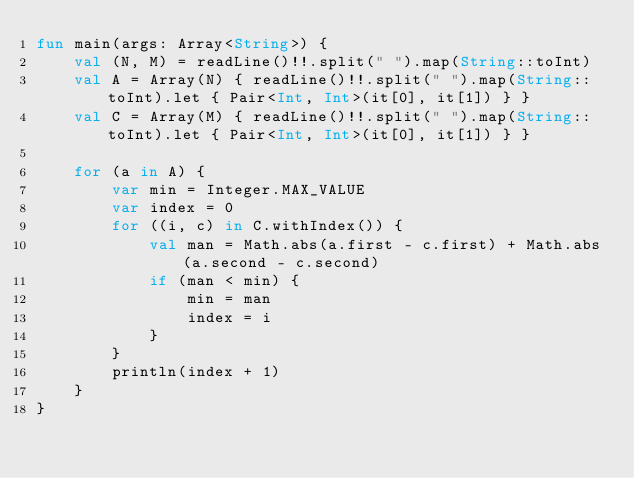Convert code to text. <code><loc_0><loc_0><loc_500><loc_500><_Kotlin_>fun main(args: Array<String>) {
    val (N, M) = readLine()!!.split(" ").map(String::toInt)
    val A = Array(N) { readLine()!!.split(" ").map(String::toInt).let { Pair<Int, Int>(it[0], it[1]) } }
    val C = Array(M) { readLine()!!.split(" ").map(String::toInt).let { Pair<Int, Int>(it[0], it[1]) } }

    for (a in A) {
        var min = Integer.MAX_VALUE
        var index = 0
        for ((i, c) in C.withIndex()) {
            val man = Math.abs(a.first - c.first) + Math.abs(a.second - c.second)
            if (man < min) {
                min = man
                index = i
            }
        }
        println(index + 1)
    }
}

</code> 